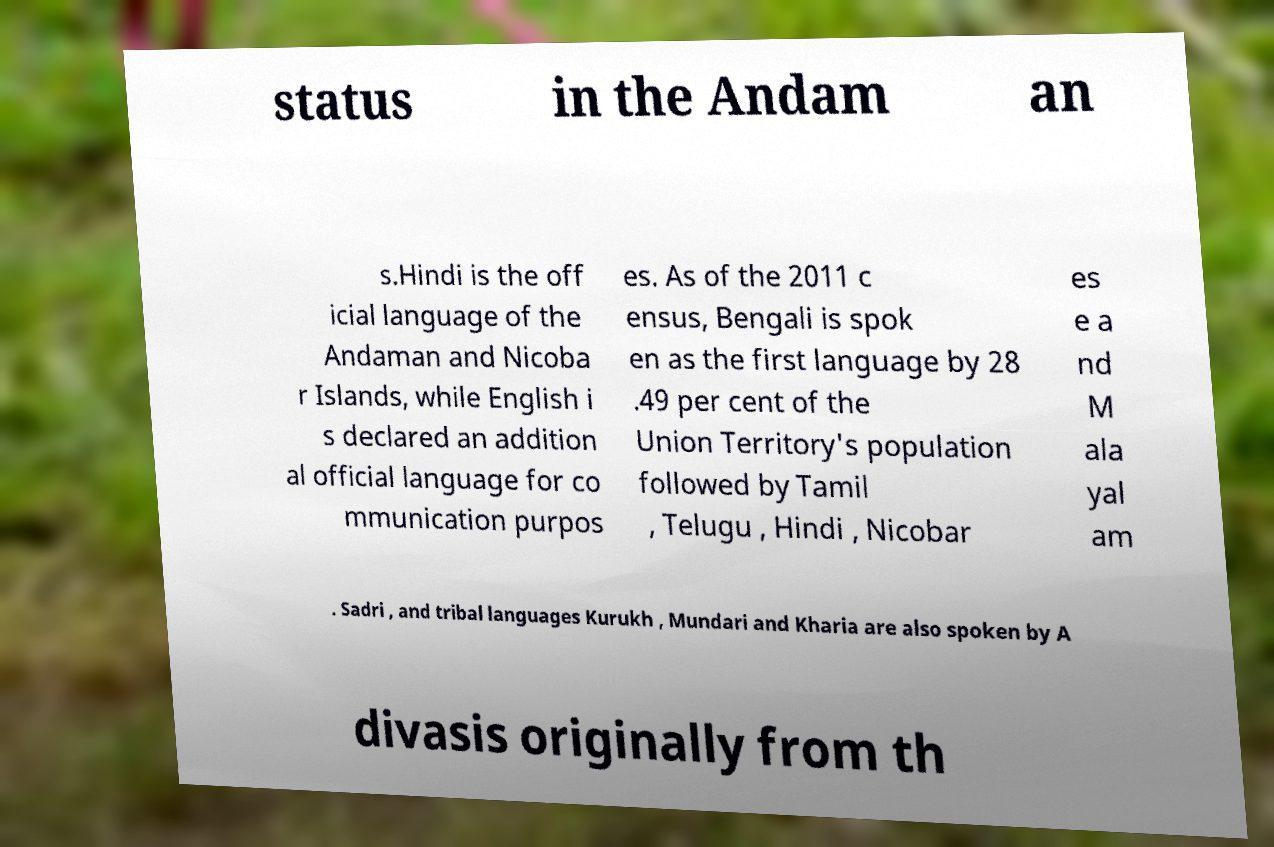For documentation purposes, I need the text within this image transcribed. Could you provide that? status in the Andam an s.Hindi is the off icial language of the Andaman and Nicoba r Islands, while English i s declared an addition al official language for co mmunication purpos es. As of the 2011 c ensus, Bengali is spok en as the first language by 28 .49 per cent of the Union Territory's population followed by Tamil , Telugu , Hindi , Nicobar es e a nd M ala yal am . Sadri , and tribal languages Kurukh , Mundari and Kharia are also spoken by A divasis originally from th 